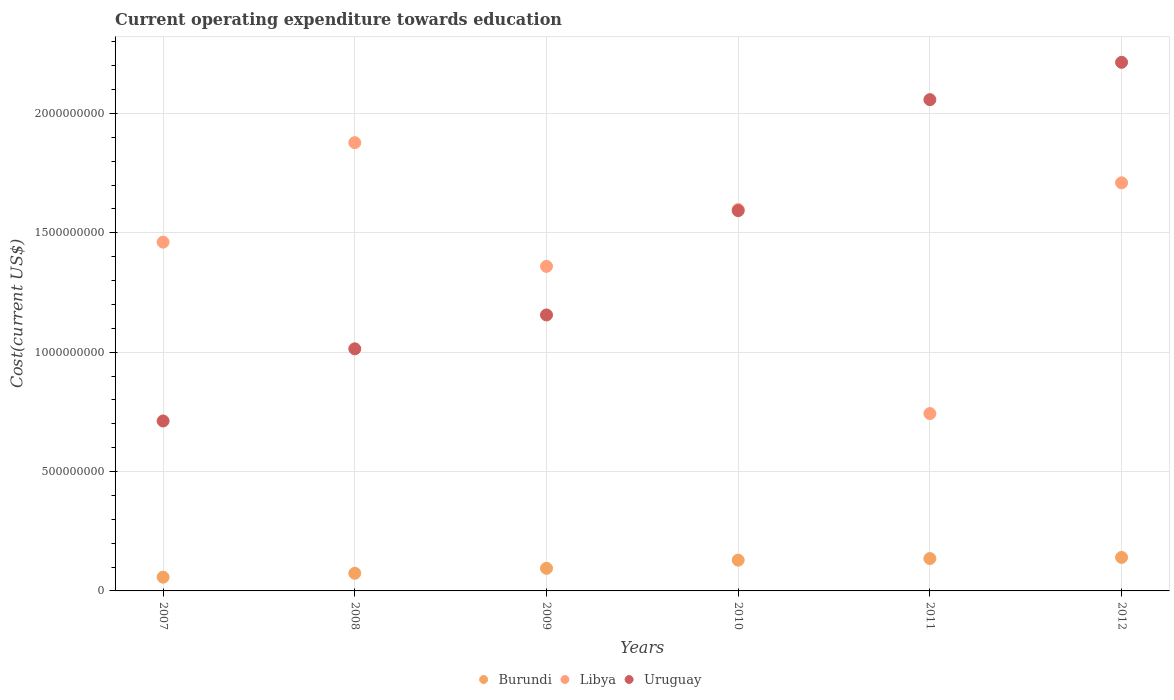What is the expenditure towards education in Libya in 2009?
Your answer should be compact. 1.36e+09. Across all years, what is the maximum expenditure towards education in Libya?
Provide a short and direct response. 1.88e+09. Across all years, what is the minimum expenditure towards education in Libya?
Make the answer very short. 7.43e+08. In which year was the expenditure towards education in Burundi maximum?
Your answer should be very brief. 2012. In which year was the expenditure towards education in Libya minimum?
Your answer should be compact. 2011. What is the total expenditure towards education in Uruguay in the graph?
Your response must be concise. 8.75e+09. What is the difference between the expenditure towards education in Uruguay in 2007 and that in 2008?
Keep it short and to the point. -3.02e+08. What is the difference between the expenditure towards education in Libya in 2011 and the expenditure towards education in Uruguay in 2012?
Offer a terse response. -1.47e+09. What is the average expenditure towards education in Burundi per year?
Give a very brief answer. 1.05e+08. In the year 2009, what is the difference between the expenditure towards education in Burundi and expenditure towards education in Uruguay?
Offer a terse response. -1.06e+09. What is the ratio of the expenditure towards education in Burundi in 2007 to that in 2011?
Keep it short and to the point. 0.42. Is the expenditure towards education in Burundi in 2007 less than that in 2011?
Provide a succinct answer. Yes. Is the difference between the expenditure towards education in Burundi in 2007 and 2010 greater than the difference between the expenditure towards education in Uruguay in 2007 and 2010?
Your response must be concise. Yes. What is the difference between the highest and the second highest expenditure towards education in Uruguay?
Offer a very short reply. 1.56e+08. What is the difference between the highest and the lowest expenditure towards education in Libya?
Offer a terse response. 1.13e+09. Is the sum of the expenditure towards education in Burundi in 2011 and 2012 greater than the maximum expenditure towards education in Uruguay across all years?
Offer a terse response. No. Is it the case that in every year, the sum of the expenditure towards education in Uruguay and expenditure towards education in Burundi  is greater than the expenditure towards education in Libya?
Provide a short and direct response. No. Does the expenditure towards education in Burundi monotonically increase over the years?
Provide a succinct answer. Yes. Is the expenditure towards education in Uruguay strictly greater than the expenditure towards education in Libya over the years?
Provide a short and direct response. No. Is the expenditure towards education in Uruguay strictly less than the expenditure towards education in Burundi over the years?
Make the answer very short. No. Does the graph contain any zero values?
Your response must be concise. No. Where does the legend appear in the graph?
Give a very brief answer. Bottom center. How are the legend labels stacked?
Provide a short and direct response. Horizontal. What is the title of the graph?
Offer a very short reply. Current operating expenditure towards education. What is the label or title of the Y-axis?
Provide a succinct answer. Cost(current US$). What is the Cost(current US$) in Burundi in 2007?
Make the answer very short. 5.76e+07. What is the Cost(current US$) of Libya in 2007?
Make the answer very short. 1.46e+09. What is the Cost(current US$) in Uruguay in 2007?
Give a very brief answer. 7.12e+08. What is the Cost(current US$) of Burundi in 2008?
Give a very brief answer. 7.39e+07. What is the Cost(current US$) of Libya in 2008?
Provide a short and direct response. 1.88e+09. What is the Cost(current US$) in Uruguay in 2008?
Give a very brief answer. 1.01e+09. What is the Cost(current US$) of Burundi in 2009?
Offer a very short reply. 9.48e+07. What is the Cost(current US$) in Libya in 2009?
Ensure brevity in your answer.  1.36e+09. What is the Cost(current US$) of Uruguay in 2009?
Offer a terse response. 1.16e+09. What is the Cost(current US$) of Burundi in 2010?
Give a very brief answer. 1.29e+08. What is the Cost(current US$) in Libya in 2010?
Your response must be concise. 1.60e+09. What is the Cost(current US$) of Uruguay in 2010?
Ensure brevity in your answer.  1.59e+09. What is the Cost(current US$) in Burundi in 2011?
Your answer should be very brief. 1.36e+08. What is the Cost(current US$) in Libya in 2011?
Keep it short and to the point. 7.43e+08. What is the Cost(current US$) of Uruguay in 2011?
Make the answer very short. 2.06e+09. What is the Cost(current US$) of Burundi in 2012?
Provide a short and direct response. 1.40e+08. What is the Cost(current US$) in Libya in 2012?
Give a very brief answer. 1.71e+09. What is the Cost(current US$) in Uruguay in 2012?
Provide a succinct answer. 2.21e+09. Across all years, what is the maximum Cost(current US$) in Burundi?
Make the answer very short. 1.40e+08. Across all years, what is the maximum Cost(current US$) of Libya?
Keep it short and to the point. 1.88e+09. Across all years, what is the maximum Cost(current US$) of Uruguay?
Ensure brevity in your answer.  2.21e+09. Across all years, what is the minimum Cost(current US$) in Burundi?
Give a very brief answer. 5.76e+07. Across all years, what is the minimum Cost(current US$) of Libya?
Your answer should be compact. 7.43e+08. Across all years, what is the minimum Cost(current US$) of Uruguay?
Your answer should be very brief. 7.12e+08. What is the total Cost(current US$) of Burundi in the graph?
Provide a succinct answer. 6.31e+08. What is the total Cost(current US$) in Libya in the graph?
Your answer should be very brief. 8.75e+09. What is the total Cost(current US$) in Uruguay in the graph?
Give a very brief answer. 8.75e+09. What is the difference between the Cost(current US$) in Burundi in 2007 and that in 2008?
Your answer should be compact. -1.63e+07. What is the difference between the Cost(current US$) in Libya in 2007 and that in 2008?
Keep it short and to the point. -4.17e+08. What is the difference between the Cost(current US$) in Uruguay in 2007 and that in 2008?
Keep it short and to the point. -3.02e+08. What is the difference between the Cost(current US$) of Burundi in 2007 and that in 2009?
Keep it short and to the point. -3.71e+07. What is the difference between the Cost(current US$) in Libya in 2007 and that in 2009?
Give a very brief answer. 1.01e+08. What is the difference between the Cost(current US$) in Uruguay in 2007 and that in 2009?
Your response must be concise. -4.44e+08. What is the difference between the Cost(current US$) of Burundi in 2007 and that in 2010?
Ensure brevity in your answer.  -7.13e+07. What is the difference between the Cost(current US$) in Libya in 2007 and that in 2010?
Give a very brief answer. -1.37e+08. What is the difference between the Cost(current US$) in Uruguay in 2007 and that in 2010?
Provide a succinct answer. -8.81e+08. What is the difference between the Cost(current US$) in Burundi in 2007 and that in 2011?
Provide a short and direct response. -7.80e+07. What is the difference between the Cost(current US$) in Libya in 2007 and that in 2011?
Your answer should be compact. 7.18e+08. What is the difference between the Cost(current US$) in Uruguay in 2007 and that in 2011?
Ensure brevity in your answer.  -1.35e+09. What is the difference between the Cost(current US$) in Burundi in 2007 and that in 2012?
Keep it short and to the point. -8.28e+07. What is the difference between the Cost(current US$) in Libya in 2007 and that in 2012?
Provide a short and direct response. -2.48e+08. What is the difference between the Cost(current US$) of Uruguay in 2007 and that in 2012?
Make the answer very short. -1.50e+09. What is the difference between the Cost(current US$) of Burundi in 2008 and that in 2009?
Give a very brief answer. -2.08e+07. What is the difference between the Cost(current US$) in Libya in 2008 and that in 2009?
Provide a succinct answer. 5.18e+08. What is the difference between the Cost(current US$) of Uruguay in 2008 and that in 2009?
Provide a succinct answer. -1.42e+08. What is the difference between the Cost(current US$) in Burundi in 2008 and that in 2010?
Your answer should be very brief. -5.50e+07. What is the difference between the Cost(current US$) in Libya in 2008 and that in 2010?
Ensure brevity in your answer.  2.80e+08. What is the difference between the Cost(current US$) of Uruguay in 2008 and that in 2010?
Make the answer very short. -5.79e+08. What is the difference between the Cost(current US$) in Burundi in 2008 and that in 2011?
Make the answer very short. -6.17e+07. What is the difference between the Cost(current US$) of Libya in 2008 and that in 2011?
Give a very brief answer. 1.13e+09. What is the difference between the Cost(current US$) of Uruguay in 2008 and that in 2011?
Your response must be concise. -1.04e+09. What is the difference between the Cost(current US$) of Burundi in 2008 and that in 2012?
Offer a very short reply. -6.65e+07. What is the difference between the Cost(current US$) in Libya in 2008 and that in 2012?
Keep it short and to the point. 1.68e+08. What is the difference between the Cost(current US$) of Uruguay in 2008 and that in 2012?
Your answer should be compact. -1.20e+09. What is the difference between the Cost(current US$) of Burundi in 2009 and that in 2010?
Offer a terse response. -3.42e+07. What is the difference between the Cost(current US$) of Libya in 2009 and that in 2010?
Your answer should be compact. -2.38e+08. What is the difference between the Cost(current US$) in Uruguay in 2009 and that in 2010?
Provide a short and direct response. -4.37e+08. What is the difference between the Cost(current US$) of Burundi in 2009 and that in 2011?
Give a very brief answer. -4.09e+07. What is the difference between the Cost(current US$) of Libya in 2009 and that in 2011?
Your answer should be compact. 6.17e+08. What is the difference between the Cost(current US$) in Uruguay in 2009 and that in 2011?
Give a very brief answer. -9.02e+08. What is the difference between the Cost(current US$) in Burundi in 2009 and that in 2012?
Give a very brief answer. -4.57e+07. What is the difference between the Cost(current US$) in Libya in 2009 and that in 2012?
Provide a short and direct response. -3.50e+08. What is the difference between the Cost(current US$) of Uruguay in 2009 and that in 2012?
Give a very brief answer. -1.06e+09. What is the difference between the Cost(current US$) in Burundi in 2010 and that in 2011?
Offer a very short reply. -6.67e+06. What is the difference between the Cost(current US$) in Libya in 2010 and that in 2011?
Offer a very short reply. 8.55e+08. What is the difference between the Cost(current US$) of Uruguay in 2010 and that in 2011?
Give a very brief answer. -4.65e+08. What is the difference between the Cost(current US$) in Burundi in 2010 and that in 2012?
Provide a short and direct response. -1.15e+07. What is the difference between the Cost(current US$) in Libya in 2010 and that in 2012?
Your response must be concise. -1.12e+08. What is the difference between the Cost(current US$) in Uruguay in 2010 and that in 2012?
Give a very brief answer. -6.21e+08. What is the difference between the Cost(current US$) in Burundi in 2011 and that in 2012?
Offer a terse response. -4.79e+06. What is the difference between the Cost(current US$) in Libya in 2011 and that in 2012?
Keep it short and to the point. -9.67e+08. What is the difference between the Cost(current US$) in Uruguay in 2011 and that in 2012?
Provide a short and direct response. -1.56e+08. What is the difference between the Cost(current US$) of Burundi in 2007 and the Cost(current US$) of Libya in 2008?
Provide a succinct answer. -1.82e+09. What is the difference between the Cost(current US$) in Burundi in 2007 and the Cost(current US$) in Uruguay in 2008?
Provide a short and direct response. -9.56e+08. What is the difference between the Cost(current US$) of Libya in 2007 and the Cost(current US$) of Uruguay in 2008?
Offer a very short reply. 4.47e+08. What is the difference between the Cost(current US$) of Burundi in 2007 and the Cost(current US$) of Libya in 2009?
Make the answer very short. -1.30e+09. What is the difference between the Cost(current US$) in Burundi in 2007 and the Cost(current US$) in Uruguay in 2009?
Ensure brevity in your answer.  -1.10e+09. What is the difference between the Cost(current US$) of Libya in 2007 and the Cost(current US$) of Uruguay in 2009?
Provide a short and direct response. 3.05e+08. What is the difference between the Cost(current US$) in Burundi in 2007 and the Cost(current US$) in Libya in 2010?
Offer a very short reply. -1.54e+09. What is the difference between the Cost(current US$) of Burundi in 2007 and the Cost(current US$) of Uruguay in 2010?
Your response must be concise. -1.54e+09. What is the difference between the Cost(current US$) of Libya in 2007 and the Cost(current US$) of Uruguay in 2010?
Keep it short and to the point. -1.32e+08. What is the difference between the Cost(current US$) in Burundi in 2007 and the Cost(current US$) in Libya in 2011?
Give a very brief answer. -6.85e+08. What is the difference between the Cost(current US$) in Burundi in 2007 and the Cost(current US$) in Uruguay in 2011?
Your response must be concise. -2.00e+09. What is the difference between the Cost(current US$) in Libya in 2007 and the Cost(current US$) in Uruguay in 2011?
Provide a short and direct response. -5.97e+08. What is the difference between the Cost(current US$) in Burundi in 2007 and the Cost(current US$) in Libya in 2012?
Your answer should be compact. -1.65e+09. What is the difference between the Cost(current US$) of Burundi in 2007 and the Cost(current US$) of Uruguay in 2012?
Offer a very short reply. -2.16e+09. What is the difference between the Cost(current US$) in Libya in 2007 and the Cost(current US$) in Uruguay in 2012?
Keep it short and to the point. -7.53e+08. What is the difference between the Cost(current US$) of Burundi in 2008 and the Cost(current US$) of Libya in 2009?
Keep it short and to the point. -1.29e+09. What is the difference between the Cost(current US$) in Burundi in 2008 and the Cost(current US$) in Uruguay in 2009?
Your response must be concise. -1.08e+09. What is the difference between the Cost(current US$) of Libya in 2008 and the Cost(current US$) of Uruguay in 2009?
Offer a terse response. 7.22e+08. What is the difference between the Cost(current US$) in Burundi in 2008 and the Cost(current US$) in Libya in 2010?
Make the answer very short. -1.52e+09. What is the difference between the Cost(current US$) in Burundi in 2008 and the Cost(current US$) in Uruguay in 2010?
Offer a very short reply. -1.52e+09. What is the difference between the Cost(current US$) of Libya in 2008 and the Cost(current US$) of Uruguay in 2010?
Offer a terse response. 2.85e+08. What is the difference between the Cost(current US$) in Burundi in 2008 and the Cost(current US$) in Libya in 2011?
Offer a very short reply. -6.69e+08. What is the difference between the Cost(current US$) in Burundi in 2008 and the Cost(current US$) in Uruguay in 2011?
Keep it short and to the point. -1.98e+09. What is the difference between the Cost(current US$) of Libya in 2008 and the Cost(current US$) of Uruguay in 2011?
Offer a very short reply. -1.80e+08. What is the difference between the Cost(current US$) in Burundi in 2008 and the Cost(current US$) in Libya in 2012?
Offer a very short reply. -1.64e+09. What is the difference between the Cost(current US$) in Burundi in 2008 and the Cost(current US$) in Uruguay in 2012?
Your answer should be very brief. -2.14e+09. What is the difference between the Cost(current US$) of Libya in 2008 and the Cost(current US$) of Uruguay in 2012?
Give a very brief answer. -3.36e+08. What is the difference between the Cost(current US$) in Burundi in 2009 and the Cost(current US$) in Libya in 2010?
Your response must be concise. -1.50e+09. What is the difference between the Cost(current US$) in Burundi in 2009 and the Cost(current US$) in Uruguay in 2010?
Give a very brief answer. -1.50e+09. What is the difference between the Cost(current US$) of Libya in 2009 and the Cost(current US$) of Uruguay in 2010?
Your response must be concise. -2.33e+08. What is the difference between the Cost(current US$) of Burundi in 2009 and the Cost(current US$) of Libya in 2011?
Ensure brevity in your answer.  -6.48e+08. What is the difference between the Cost(current US$) of Burundi in 2009 and the Cost(current US$) of Uruguay in 2011?
Your answer should be compact. -1.96e+09. What is the difference between the Cost(current US$) in Libya in 2009 and the Cost(current US$) in Uruguay in 2011?
Your answer should be very brief. -6.98e+08. What is the difference between the Cost(current US$) in Burundi in 2009 and the Cost(current US$) in Libya in 2012?
Provide a succinct answer. -1.61e+09. What is the difference between the Cost(current US$) in Burundi in 2009 and the Cost(current US$) in Uruguay in 2012?
Offer a very short reply. -2.12e+09. What is the difference between the Cost(current US$) in Libya in 2009 and the Cost(current US$) in Uruguay in 2012?
Ensure brevity in your answer.  -8.55e+08. What is the difference between the Cost(current US$) of Burundi in 2010 and the Cost(current US$) of Libya in 2011?
Offer a terse response. -6.14e+08. What is the difference between the Cost(current US$) of Burundi in 2010 and the Cost(current US$) of Uruguay in 2011?
Provide a short and direct response. -1.93e+09. What is the difference between the Cost(current US$) in Libya in 2010 and the Cost(current US$) in Uruguay in 2011?
Ensure brevity in your answer.  -4.60e+08. What is the difference between the Cost(current US$) in Burundi in 2010 and the Cost(current US$) in Libya in 2012?
Provide a short and direct response. -1.58e+09. What is the difference between the Cost(current US$) in Burundi in 2010 and the Cost(current US$) in Uruguay in 2012?
Keep it short and to the point. -2.09e+09. What is the difference between the Cost(current US$) in Libya in 2010 and the Cost(current US$) in Uruguay in 2012?
Make the answer very short. -6.17e+08. What is the difference between the Cost(current US$) of Burundi in 2011 and the Cost(current US$) of Libya in 2012?
Make the answer very short. -1.57e+09. What is the difference between the Cost(current US$) in Burundi in 2011 and the Cost(current US$) in Uruguay in 2012?
Ensure brevity in your answer.  -2.08e+09. What is the difference between the Cost(current US$) in Libya in 2011 and the Cost(current US$) in Uruguay in 2012?
Provide a succinct answer. -1.47e+09. What is the average Cost(current US$) of Burundi per year?
Your response must be concise. 1.05e+08. What is the average Cost(current US$) in Libya per year?
Offer a very short reply. 1.46e+09. What is the average Cost(current US$) of Uruguay per year?
Make the answer very short. 1.46e+09. In the year 2007, what is the difference between the Cost(current US$) of Burundi and Cost(current US$) of Libya?
Your answer should be compact. -1.40e+09. In the year 2007, what is the difference between the Cost(current US$) of Burundi and Cost(current US$) of Uruguay?
Offer a terse response. -6.54e+08. In the year 2007, what is the difference between the Cost(current US$) in Libya and Cost(current US$) in Uruguay?
Give a very brief answer. 7.49e+08. In the year 2008, what is the difference between the Cost(current US$) of Burundi and Cost(current US$) of Libya?
Provide a short and direct response. -1.80e+09. In the year 2008, what is the difference between the Cost(current US$) in Burundi and Cost(current US$) in Uruguay?
Offer a terse response. -9.40e+08. In the year 2008, what is the difference between the Cost(current US$) of Libya and Cost(current US$) of Uruguay?
Give a very brief answer. 8.64e+08. In the year 2009, what is the difference between the Cost(current US$) in Burundi and Cost(current US$) in Libya?
Keep it short and to the point. -1.26e+09. In the year 2009, what is the difference between the Cost(current US$) of Burundi and Cost(current US$) of Uruguay?
Provide a short and direct response. -1.06e+09. In the year 2009, what is the difference between the Cost(current US$) in Libya and Cost(current US$) in Uruguay?
Your response must be concise. 2.04e+08. In the year 2010, what is the difference between the Cost(current US$) of Burundi and Cost(current US$) of Libya?
Your answer should be compact. -1.47e+09. In the year 2010, what is the difference between the Cost(current US$) in Burundi and Cost(current US$) in Uruguay?
Offer a terse response. -1.46e+09. In the year 2010, what is the difference between the Cost(current US$) of Libya and Cost(current US$) of Uruguay?
Offer a very short reply. 4.67e+06. In the year 2011, what is the difference between the Cost(current US$) in Burundi and Cost(current US$) in Libya?
Provide a succinct answer. -6.07e+08. In the year 2011, what is the difference between the Cost(current US$) in Burundi and Cost(current US$) in Uruguay?
Make the answer very short. -1.92e+09. In the year 2011, what is the difference between the Cost(current US$) in Libya and Cost(current US$) in Uruguay?
Make the answer very short. -1.31e+09. In the year 2012, what is the difference between the Cost(current US$) in Burundi and Cost(current US$) in Libya?
Make the answer very short. -1.57e+09. In the year 2012, what is the difference between the Cost(current US$) of Burundi and Cost(current US$) of Uruguay?
Your answer should be very brief. -2.07e+09. In the year 2012, what is the difference between the Cost(current US$) in Libya and Cost(current US$) in Uruguay?
Your answer should be compact. -5.05e+08. What is the ratio of the Cost(current US$) in Burundi in 2007 to that in 2008?
Provide a succinct answer. 0.78. What is the ratio of the Cost(current US$) of Libya in 2007 to that in 2008?
Your answer should be compact. 0.78. What is the ratio of the Cost(current US$) in Uruguay in 2007 to that in 2008?
Offer a very short reply. 0.7. What is the ratio of the Cost(current US$) of Burundi in 2007 to that in 2009?
Your answer should be compact. 0.61. What is the ratio of the Cost(current US$) of Libya in 2007 to that in 2009?
Your answer should be compact. 1.07. What is the ratio of the Cost(current US$) of Uruguay in 2007 to that in 2009?
Provide a short and direct response. 0.62. What is the ratio of the Cost(current US$) of Burundi in 2007 to that in 2010?
Provide a short and direct response. 0.45. What is the ratio of the Cost(current US$) of Libya in 2007 to that in 2010?
Keep it short and to the point. 0.91. What is the ratio of the Cost(current US$) in Uruguay in 2007 to that in 2010?
Offer a terse response. 0.45. What is the ratio of the Cost(current US$) of Burundi in 2007 to that in 2011?
Your answer should be very brief. 0.42. What is the ratio of the Cost(current US$) of Libya in 2007 to that in 2011?
Your answer should be very brief. 1.97. What is the ratio of the Cost(current US$) of Uruguay in 2007 to that in 2011?
Ensure brevity in your answer.  0.35. What is the ratio of the Cost(current US$) of Burundi in 2007 to that in 2012?
Give a very brief answer. 0.41. What is the ratio of the Cost(current US$) in Libya in 2007 to that in 2012?
Make the answer very short. 0.85. What is the ratio of the Cost(current US$) of Uruguay in 2007 to that in 2012?
Ensure brevity in your answer.  0.32. What is the ratio of the Cost(current US$) of Burundi in 2008 to that in 2009?
Offer a very short reply. 0.78. What is the ratio of the Cost(current US$) in Libya in 2008 to that in 2009?
Offer a terse response. 1.38. What is the ratio of the Cost(current US$) in Uruguay in 2008 to that in 2009?
Your answer should be compact. 0.88. What is the ratio of the Cost(current US$) in Burundi in 2008 to that in 2010?
Make the answer very short. 0.57. What is the ratio of the Cost(current US$) in Libya in 2008 to that in 2010?
Provide a succinct answer. 1.18. What is the ratio of the Cost(current US$) in Uruguay in 2008 to that in 2010?
Ensure brevity in your answer.  0.64. What is the ratio of the Cost(current US$) of Burundi in 2008 to that in 2011?
Make the answer very short. 0.55. What is the ratio of the Cost(current US$) in Libya in 2008 to that in 2011?
Your response must be concise. 2.53. What is the ratio of the Cost(current US$) of Uruguay in 2008 to that in 2011?
Offer a terse response. 0.49. What is the ratio of the Cost(current US$) of Burundi in 2008 to that in 2012?
Offer a terse response. 0.53. What is the ratio of the Cost(current US$) of Libya in 2008 to that in 2012?
Offer a terse response. 1.1. What is the ratio of the Cost(current US$) in Uruguay in 2008 to that in 2012?
Keep it short and to the point. 0.46. What is the ratio of the Cost(current US$) of Burundi in 2009 to that in 2010?
Ensure brevity in your answer.  0.73. What is the ratio of the Cost(current US$) of Libya in 2009 to that in 2010?
Make the answer very short. 0.85. What is the ratio of the Cost(current US$) of Uruguay in 2009 to that in 2010?
Offer a terse response. 0.73. What is the ratio of the Cost(current US$) of Burundi in 2009 to that in 2011?
Make the answer very short. 0.7. What is the ratio of the Cost(current US$) of Libya in 2009 to that in 2011?
Provide a succinct answer. 1.83. What is the ratio of the Cost(current US$) of Uruguay in 2009 to that in 2011?
Your response must be concise. 0.56. What is the ratio of the Cost(current US$) of Burundi in 2009 to that in 2012?
Your response must be concise. 0.67. What is the ratio of the Cost(current US$) of Libya in 2009 to that in 2012?
Keep it short and to the point. 0.8. What is the ratio of the Cost(current US$) in Uruguay in 2009 to that in 2012?
Provide a succinct answer. 0.52. What is the ratio of the Cost(current US$) of Burundi in 2010 to that in 2011?
Make the answer very short. 0.95. What is the ratio of the Cost(current US$) in Libya in 2010 to that in 2011?
Offer a terse response. 2.15. What is the ratio of the Cost(current US$) of Uruguay in 2010 to that in 2011?
Your response must be concise. 0.77. What is the ratio of the Cost(current US$) in Burundi in 2010 to that in 2012?
Your answer should be very brief. 0.92. What is the ratio of the Cost(current US$) in Libya in 2010 to that in 2012?
Your answer should be very brief. 0.93. What is the ratio of the Cost(current US$) in Uruguay in 2010 to that in 2012?
Offer a terse response. 0.72. What is the ratio of the Cost(current US$) of Burundi in 2011 to that in 2012?
Offer a terse response. 0.97. What is the ratio of the Cost(current US$) of Libya in 2011 to that in 2012?
Offer a very short reply. 0.43. What is the ratio of the Cost(current US$) of Uruguay in 2011 to that in 2012?
Give a very brief answer. 0.93. What is the difference between the highest and the second highest Cost(current US$) of Burundi?
Make the answer very short. 4.79e+06. What is the difference between the highest and the second highest Cost(current US$) of Libya?
Your answer should be very brief. 1.68e+08. What is the difference between the highest and the second highest Cost(current US$) in Uruguay?
Ensure brevity in your answer.  1.56e+08. What is the difference between the highest and the lowest Cost(current US$) in Burundi?
Keep it short and to the point. 8.28e+07. What is the difference between the highest and the lowest Cost(current US$) in Libya?
Your response must be concise. 1.13e+09. What is the difference between the highest and the lowest Cost(current US$) in Uruguay?
Make the answer very short. 1.50e+09. 